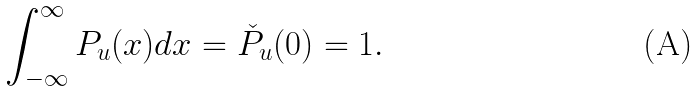<formula> <loc_0><loc_0><loc_500><loc_500>\int _ { - \infty } ^ { \infty } P _ { u } ( x ) d x = \check { P } _ { u } ( 0 ) = 1 .</formula> 